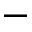<formula> <loc_0><loc_0><loc_500><loc_500>-</formula> 